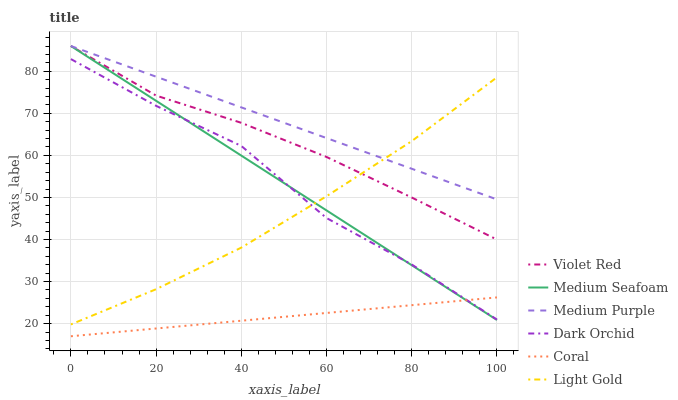Does Coral have the minimum area under the curve?
Answer yes or no. Yes. Does Medium Purple have the maximum area under the curve?
Answer yes or no. Yes. Does Dark Orchid have the minimum area under the curve?
Answer yes or no. No. Does Dark Orchid have the maximum area under the curve?
Answer yes or no. No. Is Coral the smoothest?
Answer yes or no. Yes. Is Dark Orchid the roughest?
Answer yes or no. Yes. Is Dark Orchid the smoothest?
Answer yes or no. No. Is Coral the roughest?
Answer yes or no. No. Does Coral have the lowest value?
Answer yes or no. Yes. Does Dark Orchid have the lowest value?
Answer yes or no. No. Does Medium Seafoam have the highest value?
Answer yes or no. Yes. Does Dark Orchid have the highest value?
Answer yes or no. No. Is Coral less than Medium Purple?
Answer yes or no. Yes. Is Medium Purple greater than Coral?
Answer yes or no. Yes. Does Light Gold intersect Medium Seafoam?
Answer yes or no. Yes. Is Light Gold less than Medium Seafoam?
Answer yes or no. No. Is Light Gold greater than Medium Seafoam?
Answer yes or no. No. Does Coral intersect Medium Purple?
Answer yes or no. No. 